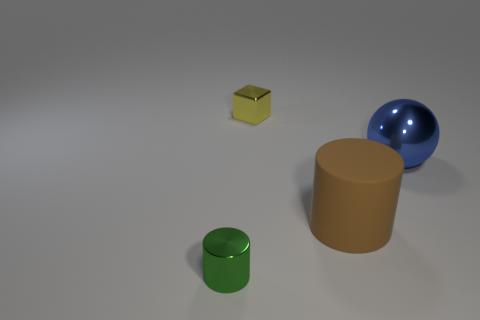Subtract all red cylinders. Subtract all yellow cubes. How many cylinders are left? 2 Add 3 green objects. How many objects exist? 7 Subtract all balls. How many objects are left? 3 Add 2 yellow balls. How many yellow balls exist? 2 Subtract 0 gray cubes. How many objects are left? 4 Subtract all big metal balls. Subtract all tiny cylinders. How many objects are left? 2 Add 2 tiny yellow blocks. How many tiny yellow blocks are left? 3 